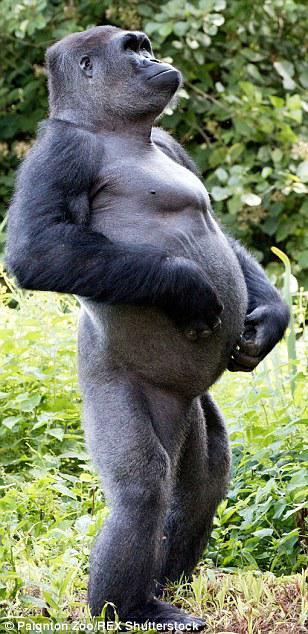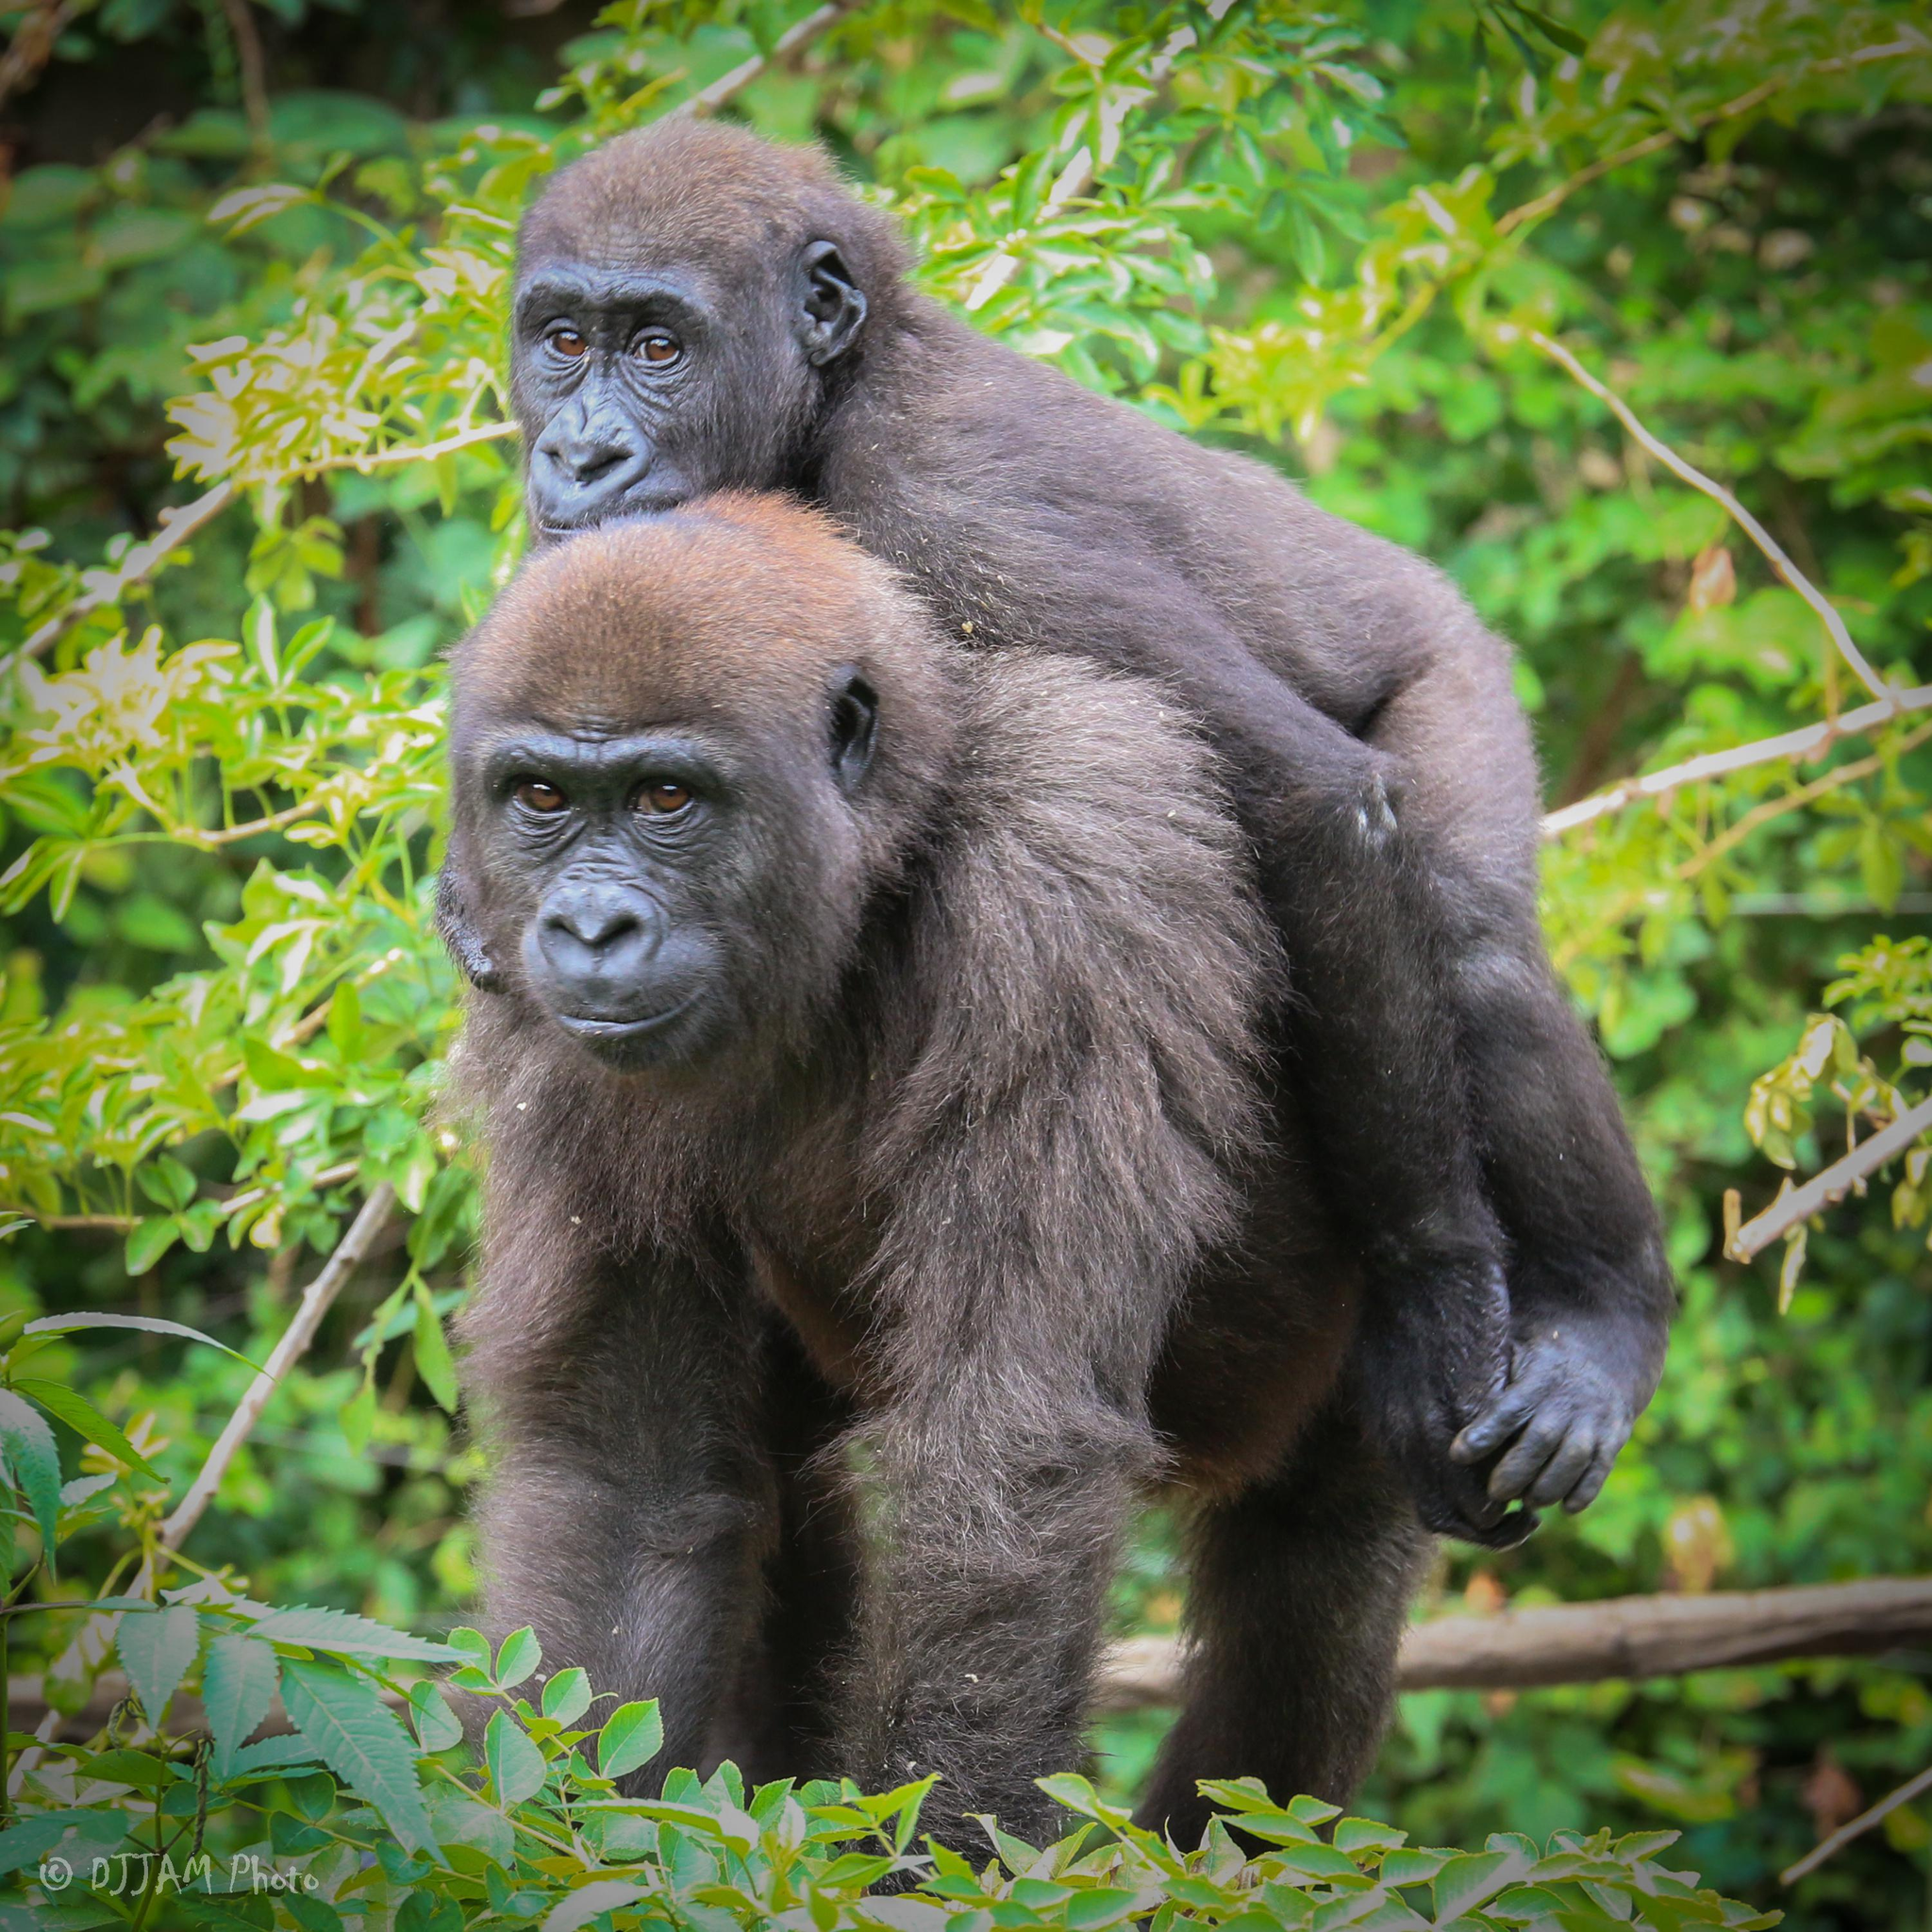The first image is the image on the left, the second image is the image on the right. Considering the images on both sides, is "the left and right image contains the same number of gorillas." valid? Answer yes or no. No. The first image is the image on the left, the second image is the image on the right. Considering the images on both sides, is "There is a silverback gorilla sitting while crossing his arm over the other" valid? Answer yes or no. No. 